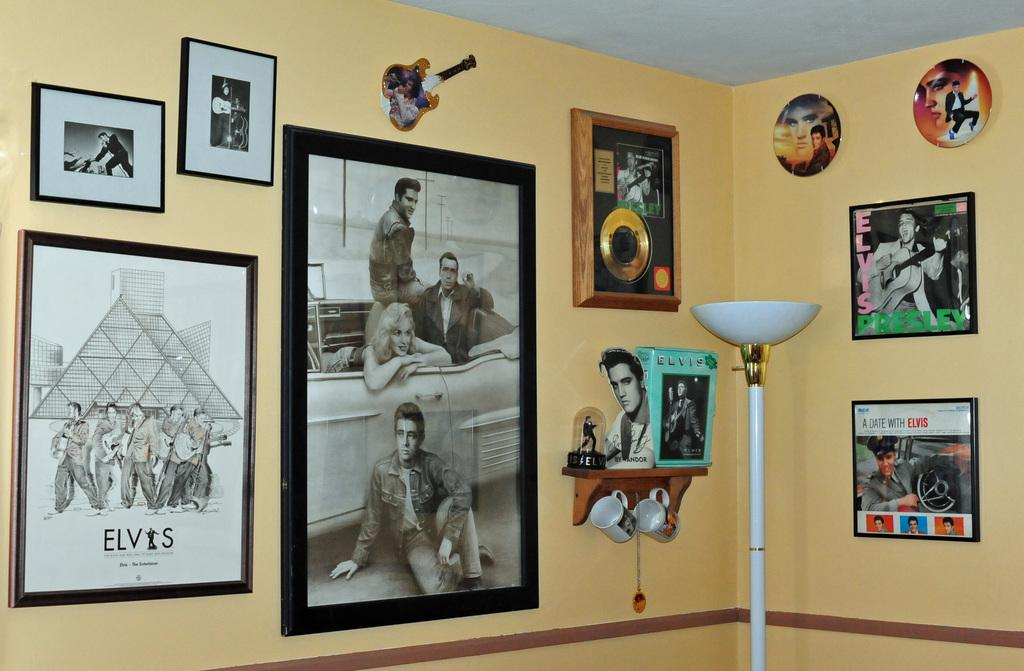What is hanging on the wall in the image? There are frames on the wall in the image. What type of objects can be seen in the image besides the frames? There are cups and a trophy in the image. What type of test is being conducted in the image? There is no test being conducted in the image; it only shows frames on the wall, cups, and a trophy. Which company is responsible for the trophy in the image? There is no information about the company responsible for the trophy in the image. 